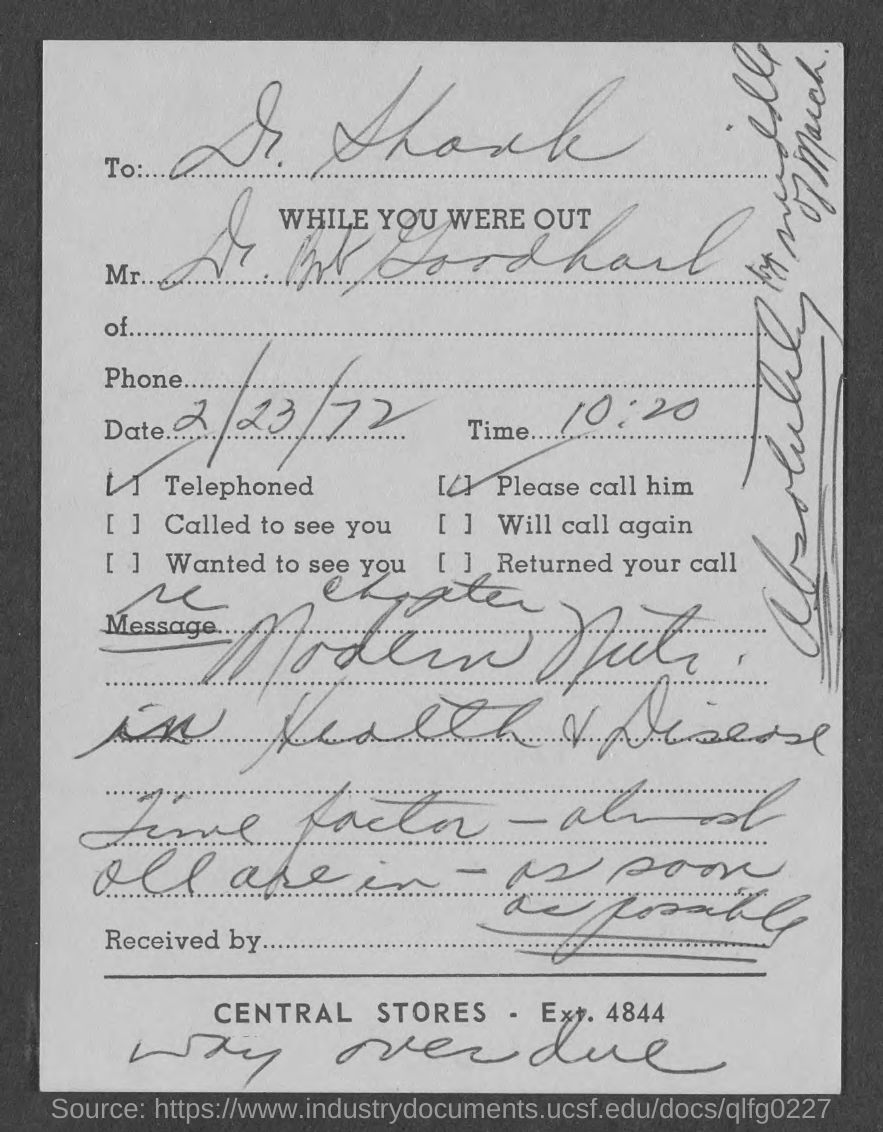What is the date mentioned in this document?
Give a very brief answer. 2/23/72. What is the time mentioned in this document?
Provide a short and direct response. 10:20. To whom, the document is addressed?
Your answer should be very brief. Dr. Shank. 